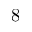Convert formula to latex. <formula><loc_0><loc_0><loc_500><loc_500>8</formula> 